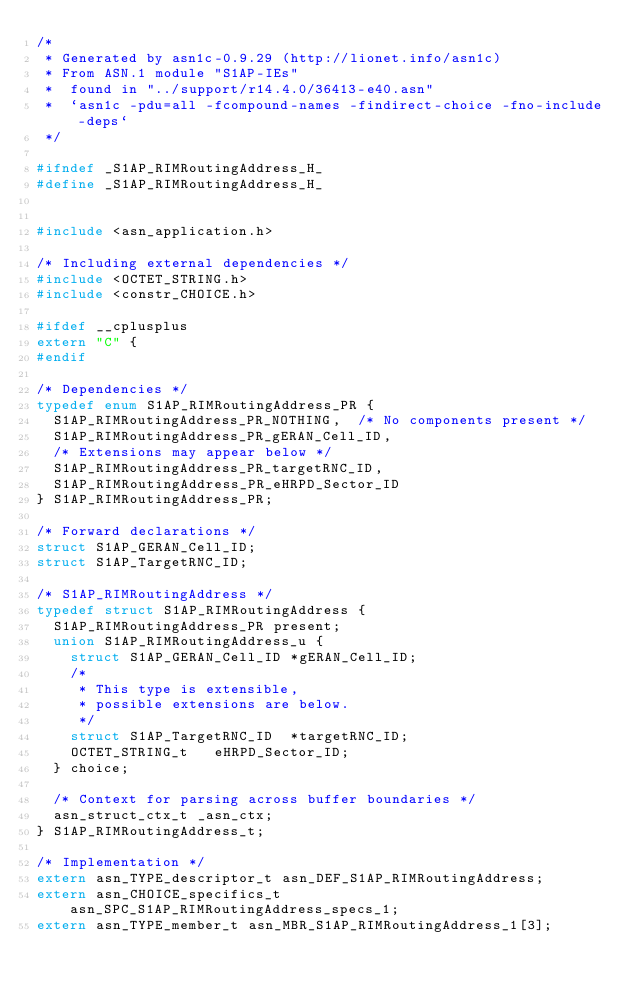Convert code to text. <code><loc_0><loc_0><loc_500><loc_500><_C_>/*
 * Generated by asn1c-0.9.29 (http://lionet.info/asn1c)
 * From ASN.1 module "S1AP-IEs"
 * 	found in "../support/r14.4.0/36413-e40.asn"
 * 	`asn1c -pdu=all -fcompound-names -findirect-choice -fno-include-deps`
 */

#ifndef	_S1AP_RIMRoutingAddress_H_
#define	_S1AP_RIMRoutingAddress_H_


#include <asn_application.h>

/* Including external dependencies */
#include <OCTET_STRING.h>
#include <constr_CHOICE.h>

#ifdef __cplusplus
extern "C" {
#endif

/* Dependencies */
typedef enum S1AP_RIMRoutingAddress_PR {
	S1AP_RIMRoutingAddress_PR_NOTHING,	/* No components present */
	S1AP_RIMRoutingAddress_PR_gERAN_Cell_ID,
	/* Extensions may appear below */
	S1AP_RIMRoutingAddress_PR_targetRNC_ID,
	S1AP_RIMRoutingAddress_PR_eHRPD_Sector_ID
} S1AP_RIMRoutingAddress_PR;

/* Forward declarations */
struct S1AP_GERAN_Cell_ID;
struct S1AP_TargetRNC_ID;

/* S1AP_RIMRoutingAddress */
typedef struct S1AP_RIMRoutingAddress {
	S1AP_RIMRoutingAddress_PR present;
	union S1AP_RIMRoutingAddress_u {
		struct S1AP_GERAN_Cell_ID	*gERAN_Cell_ID;
		/*
		 * This type is extensible,
		 * possible extensions are below.
		 */
		struct S1AP_TargetRNC_ID	*targetRNC_ID;
		OCTET_STRING_t	 eHRPD_Sector_ID;
	} choice;
	
	/* Context for parsing across buffer boundaries */
	asn_struct_ctx_t _asn_ctx;
} S1AP_RIMRoutingAddress_t;

/* Implementation */
extern asn_TYPE_descriptor_t asn_DEF_S1AP_RIMRoutingAddress;
extern asn_CHOICE_specifics_t asn_SPC_S1AP_RIMRoutingAddress_specs_1;
extern asn_TYPE_member_t asn_MBR_S1AP_RIMRoutingAddress_1[3];</code> 